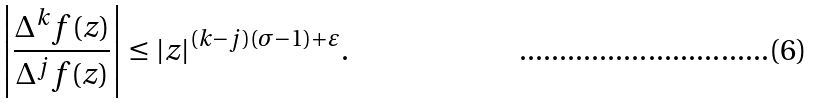Convert formula to latex. <formula><loc_0><loc_0><loc_500><loc_500>\left | \frac { \Delta ^ { k } f ( z ) } { \Delta ^ { j } f ( z ) } \right | \leq | z | ^ { ( k - j ) ( \sigma - 1 ) + \varepsilon } .</formula> 